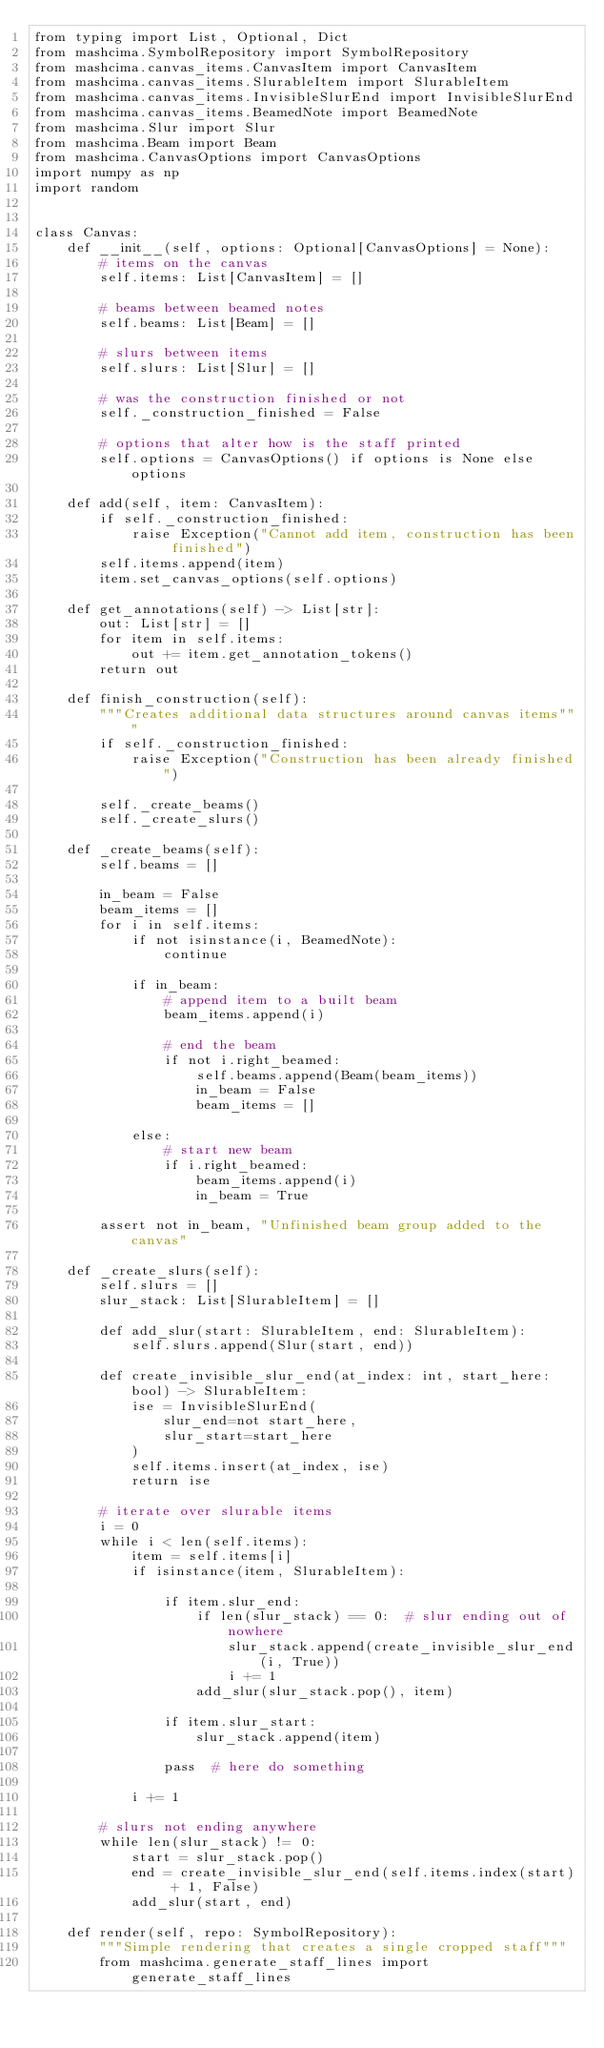<code> <loc_0><loc_0><loc_500><loc_500><_Python_>from typing import List, Optional, Dict
from mashcima.SymbolRepository import SymbolRepository
from mashcima.canvas_items.CanvasItem import CanvasItem
from mashcima.canvas_items.SlurableItem import SlurableItem
from mashcima.canvas_items.InvisibleSlurEnd import InvisibleSlurEnd
from mashcima.canvas_items.BeamedNote import BeamedNote
from mashcima.Slur import Slur
from mashcima.Beam import Beam
from mashcima.CanvasOptions import CanvasOptions
import numpy as np
import random


class Canvas:
    def __init__(self, options: Optional[CanvasOptions] = None):
        # items on the canvas
        self.items: List[CanvasItem] = []

        # beams between beamed notes
        self.beams: List[Beam] = []

        # slurs between items
        self.slurs: List[Slur] = []

        # was the construction finished or not
        self._construction_finished = False

        # options that alter how is the staff printed
        self.options = CanvasOptions() if options is None else options
        
    def add(self, item: CanvasItem):
        if self._construction_finished:
            raise Exception("Cannot add item, construction has been finished")
        self.items.append(item)
        item.set_canvas_options(self.options)

    def get_annotations(self) -> List[str]:
        out: List[str] = []
        for item in self.items:
            out += item.get_annotation_tokens()
        return out

    def finish_construction(self):
        """Creates additional data structures around canvas items"""
        if self._construction_finished:
            raise Exception("Construction has been already finished")

        self._create_beams()
        self._create_slurs()

    def _create_beams(self):
        self.beams = []

        in_beam = False
        beam_items = []
        for i in self.items:
            if not isinstance(i, BeamedNote):
                continue

            if in_beam:
                # append item to a built beam
                beam_items.append(i)

                # end the beam
                if not i.right_beamed:
                    self.beams.append(Beam(beam_items))
                    in_beam = False
                    beam_items = []

            else:
                # start new beam
                if i.right_beamed:
                    beam_items.append(i)
                    in_beam = True

        assert not in_beam, "Unfinished beam group added to the canvas"

    def _create_slurs(self):
        self.slurs = []
        slur_stack: List[SlurableItem] = []

        def add_slur(start: SlurableItem, end: SlurableItem):
            self.slurs.append(Slur(start, end))

        def create_invisible_slur_end(at_index: int, start_here: bool) -> SlurableItem:
            ise = InvisibleSlurEnd(
                slur_end=not start_here,
                slur_start=start_here
            )
            self.items.insert(at_index, ise)
            return ise

        # iterate over slurable items
        i = 0
        while i < len(self.items):
            item = self.items[i]
            if isinstance(item, SlurableItem):

                if item.slur_end:
                    if len(slur_stack) == 0:  # slur ending out of nowhere
                        slur_stack.append(create_invisible_slur_end(i, True))
                        i += 1
                    add_slur(slur_stack.pop(), item)

                if item.slur_start:
                    slur_stack.append(item)

                pass  # here do something

            i += 1

        # slurs not ending anywhere
        while len(slur_stack) != 0:
            start = slur_stack.pop()
            end = create_invisible_slur_end(self.items.index(start) + 1, False)
            add_slur(start, end)

    def render(self, repo: SymbolRepository):
        """Simple rendering that creates a single cropped staff"""
        from mashcima.generate_staff_lines import generate_staff_lines</code> 